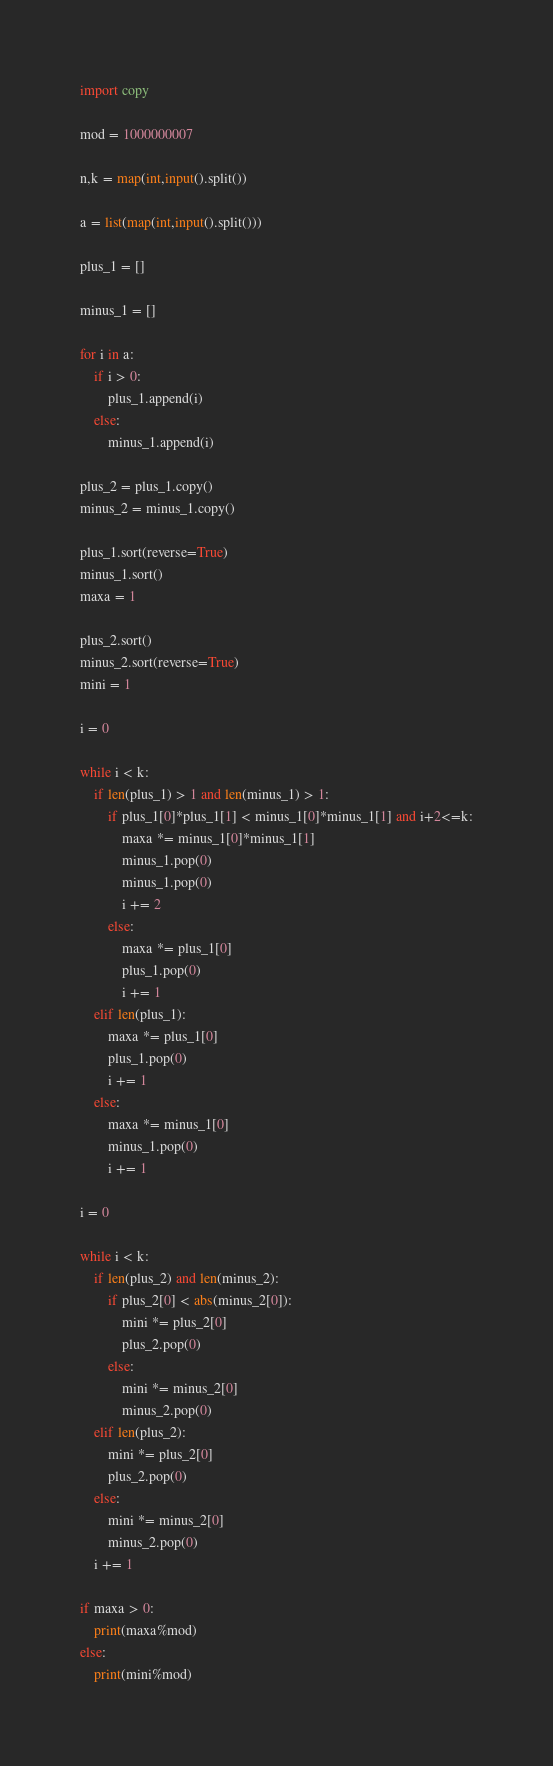<code> <loc_0><loc_0><loc_500><loc_500><_Python_>import copy

mod = 1000000007

n,k = map(int,input().split())

a = list(map(int,input().split()))

plus_1 = []

minus_1 = []

for i in a:
    if i > 0:
        plus_1.append(i)
    else:
        minus_1.append(i)

plus_2 = plus_1.copy()
minus_2 = minus_1.copy()

plus_1.sort(reverse=True)
minus_1.sort()
maxa = 1

plus_2.sort()
minus_2.sort(reverse=True)
mini = 1

i = 0

while i < k:
    if len(plus_1) > 1 and len(minus_1) > 1:
        if plus_1[0]*plus_1[1] < minus_1[0]*minus_1[1] and i+2<=k:
            maxa *= minus_1[0]*minus_1[1]
            minus_1.pop(0)
            minus_1.pop(0)
            i += 2
        else:
            maxa *= plus_1[0]
            plus_1.pop(0)
            i += 1
    elif len(plus_1):
        maxa *= plus_1[0]
        plus_1.pop(0)
        i += 1
    else:
        maxa *= minus_1[0]
        minus_1.pop(0)
        i += 1

i = 0

while i < k:
    if len(plus_2) and len(minus_2):
        if plus_2[0] < abs(minus_2[0]):
            mini *= plus_2[0]
            plus_2.pop(0)
        else:
            mini *= minus_2[0]
            minus_2.pop(0)
    elif len(plus_2):
        mini *= plus_2[0]
        plus_2.pop(0)
    else:
        mini *= minus_2[0]
        minus_2.pop(0)
    i += 1

if maxa > 0:
    print(maxa%mod)
else:
    print(mini%mod)</code> 